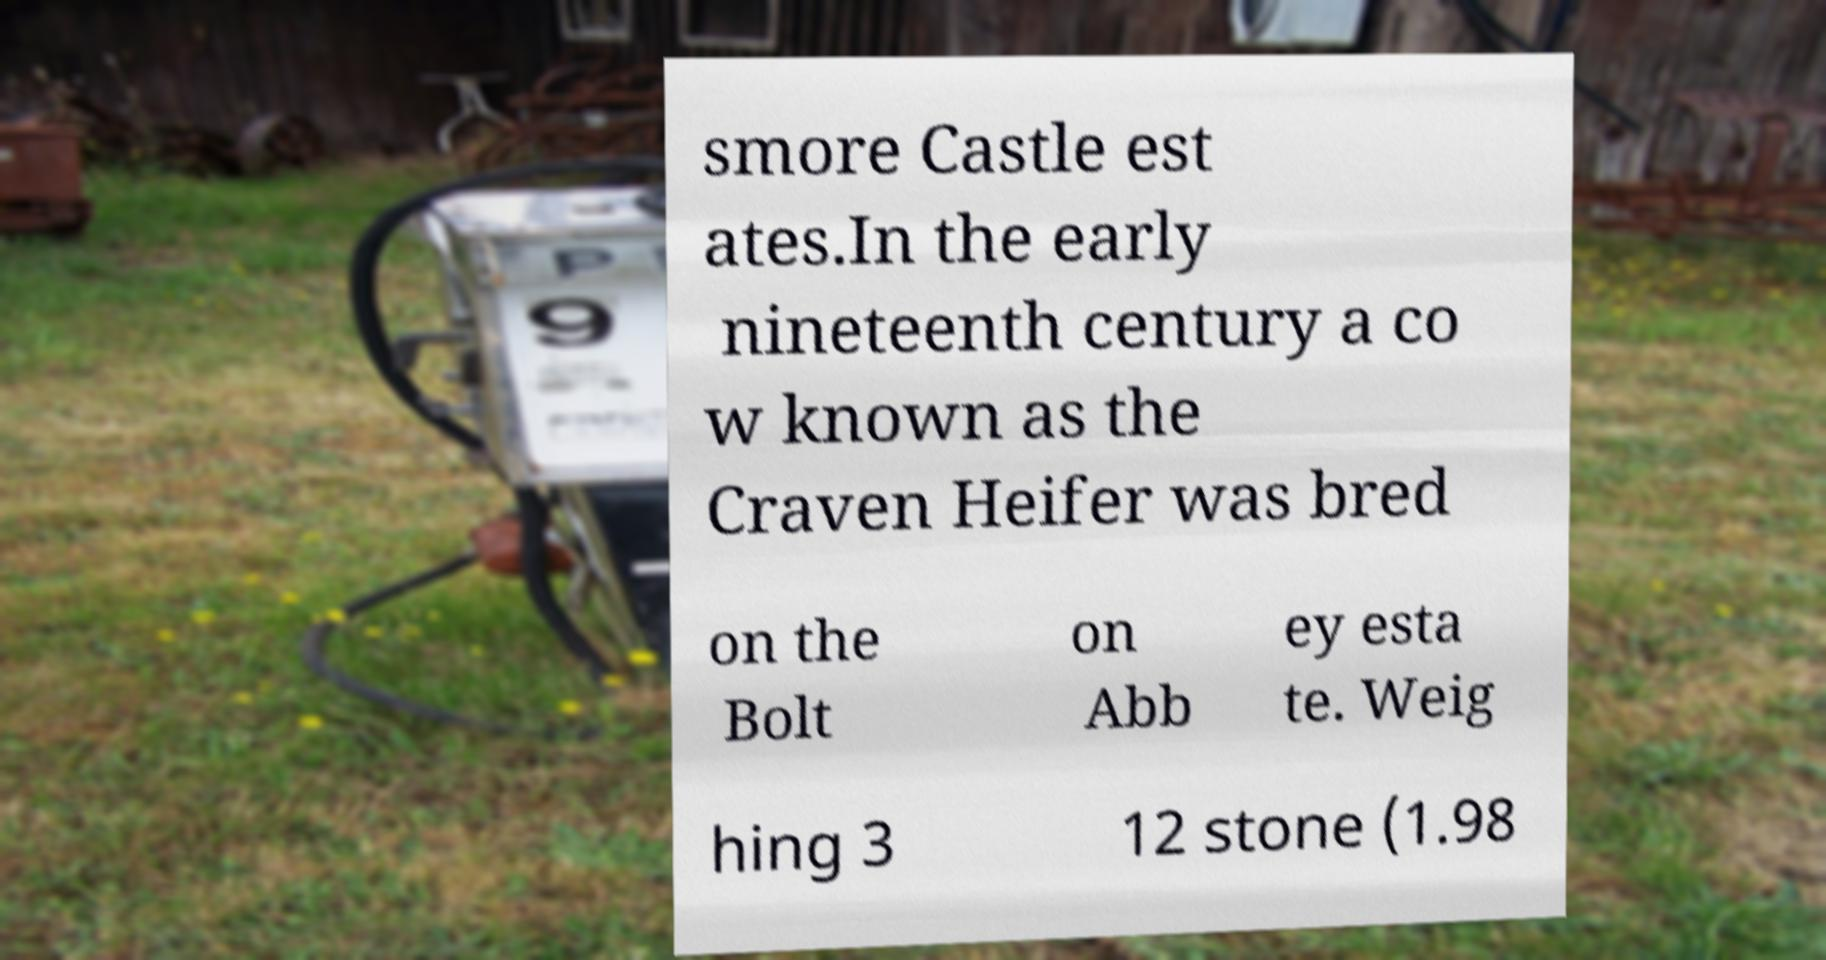For documentation purposes, I need the text within this image transcribed. Could you provide that? smore Castle est ates.In the early nineteenth century a co w known as the Craven Heifer was bred on the Bolt on Abb ey esta te. Weig hing 3 12 stone (1.98 